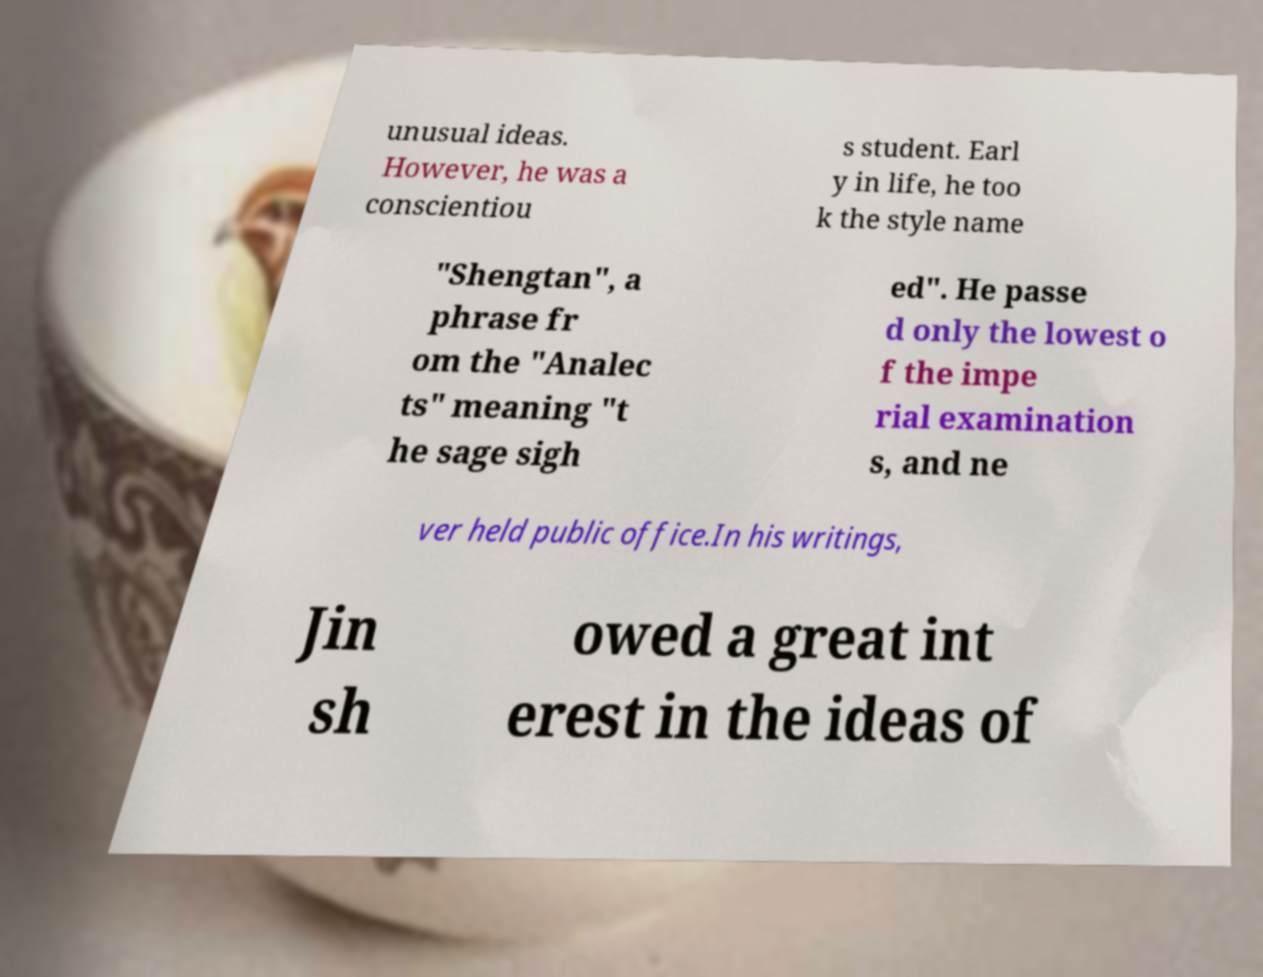Could you assist in decoding the text presented in this image and type it out clearly? unusual ideas. However, he was a conscientiou s student. Earl y in life, he too k the style name "Shengtan", a phrase fr om the "Analec ts" meaning "t he sage sigh ed". He passe d only the lowest o f the impe rial examination s, and ne ver held public office.In his writings, Jin sh owed a great int erest in the ideas of 